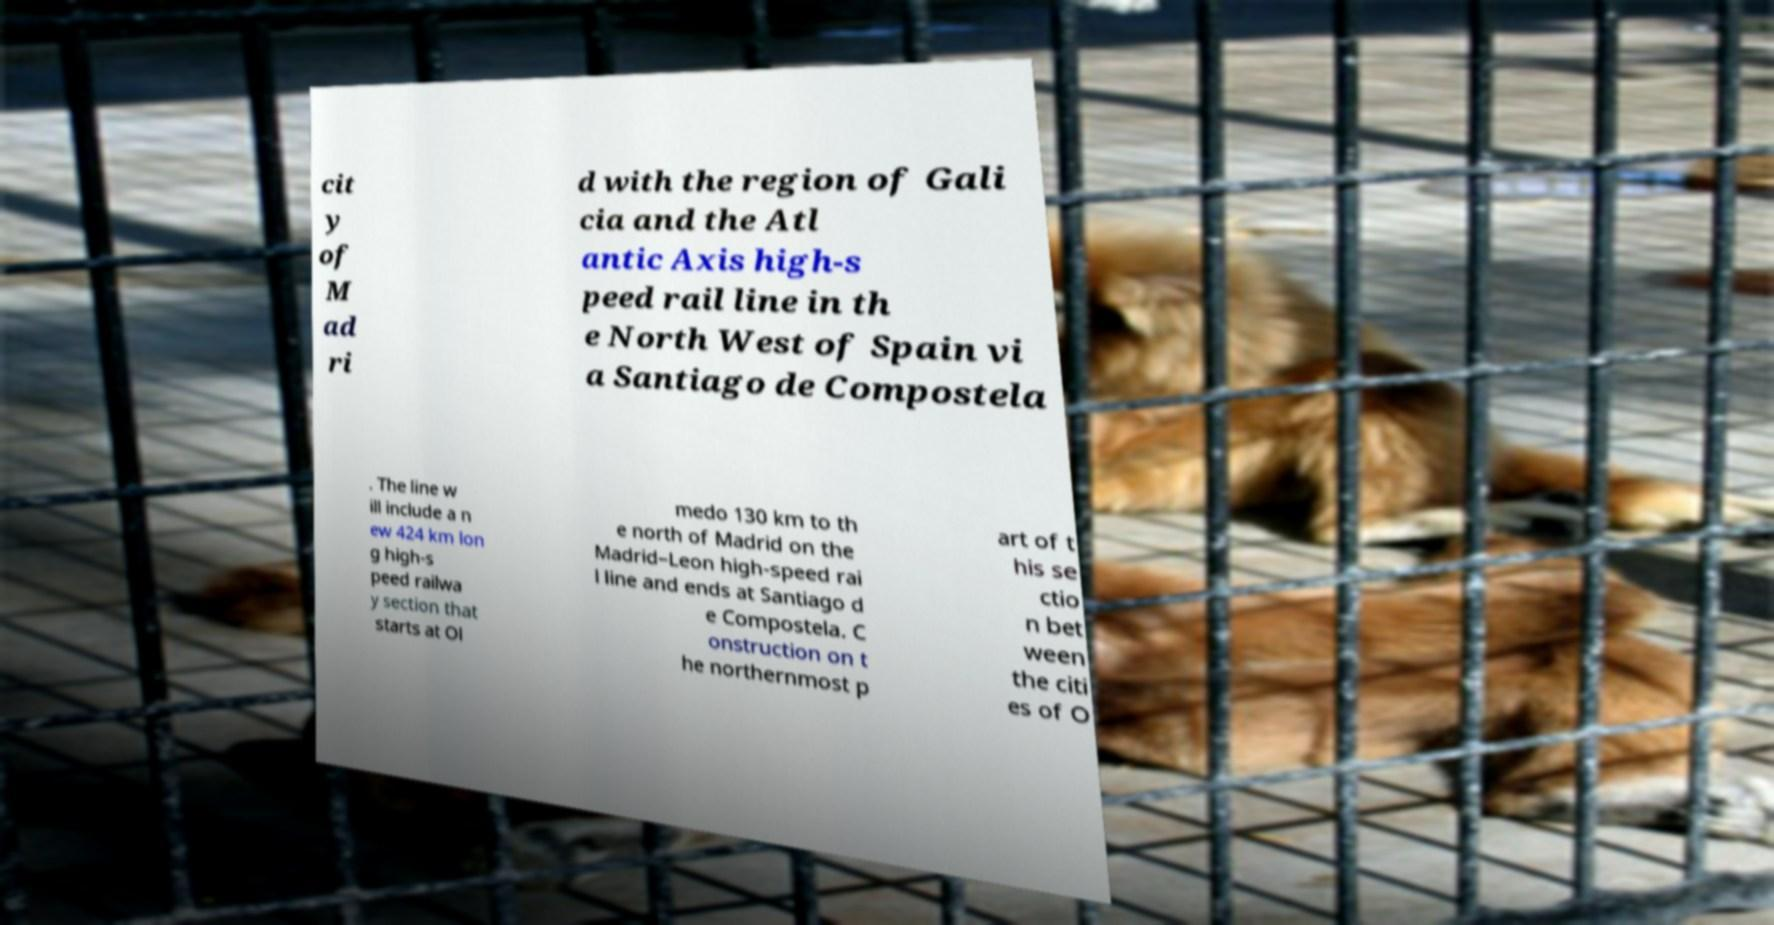There's text embedded in this image that I need extracted. Can you transcribe it verbatim? cit y of M ad ri d with the region of Gali cia and the Atl antic Axis high-s peed rail line in th e North West of Spain vi a Santiago de Compostela . The line w ill include a n ew 424 km lon g high-s peed railwa y section that starts at Ol medo 130 km to th e north of Madrid on the Madrid–Leon high-speed rai l line and ends at Santiago d e Compostela. C onstruction on t he northernmost p art of t his se ctio n bet ween the citi es of O 